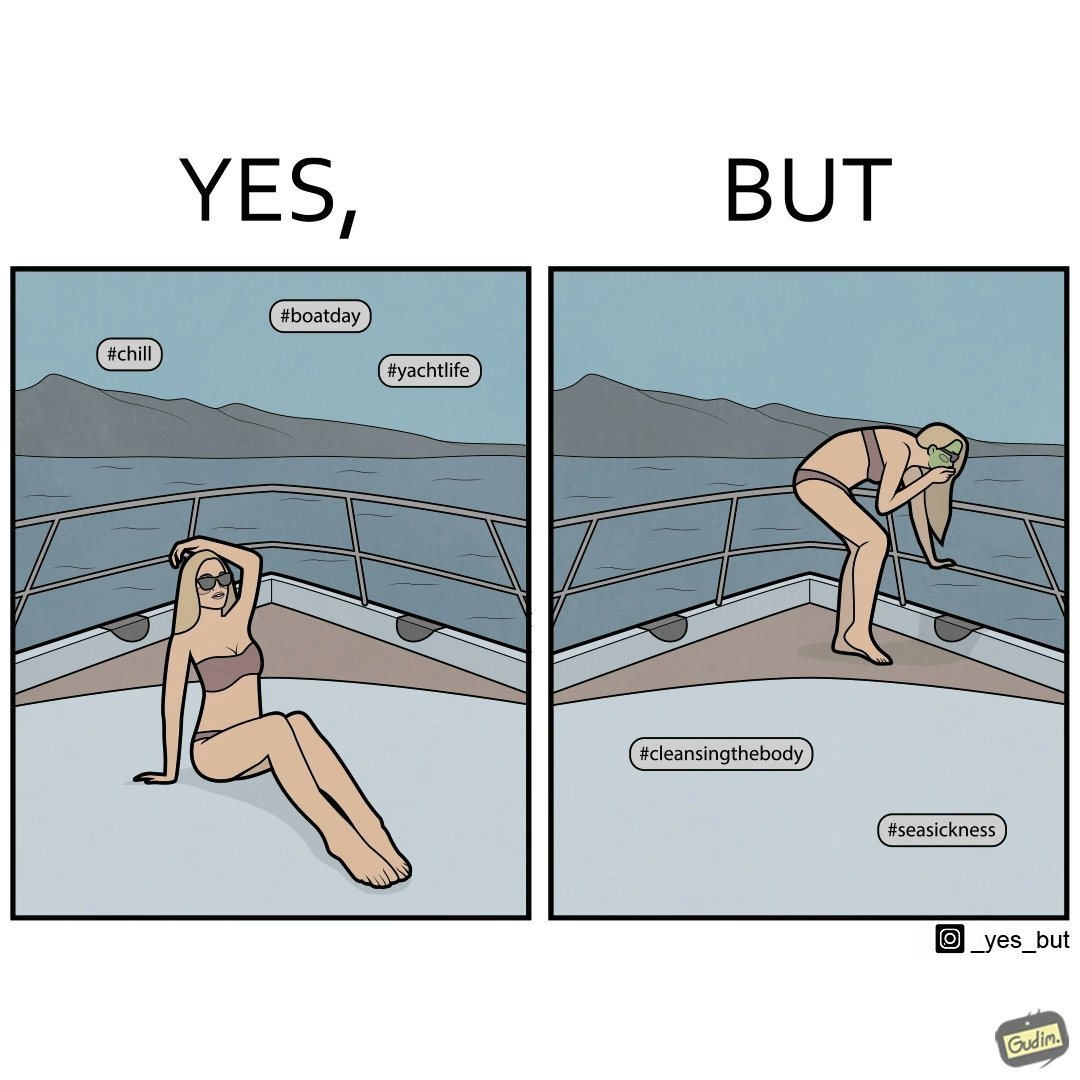What is shown in the left half versus the right half of this image? In the left part of the image: a woman posing for a photo on a sea trip on how she is enjoying the trip In the right part of the image: a woman in a photo on a sea trip shown how she is feeling sick over the trip 